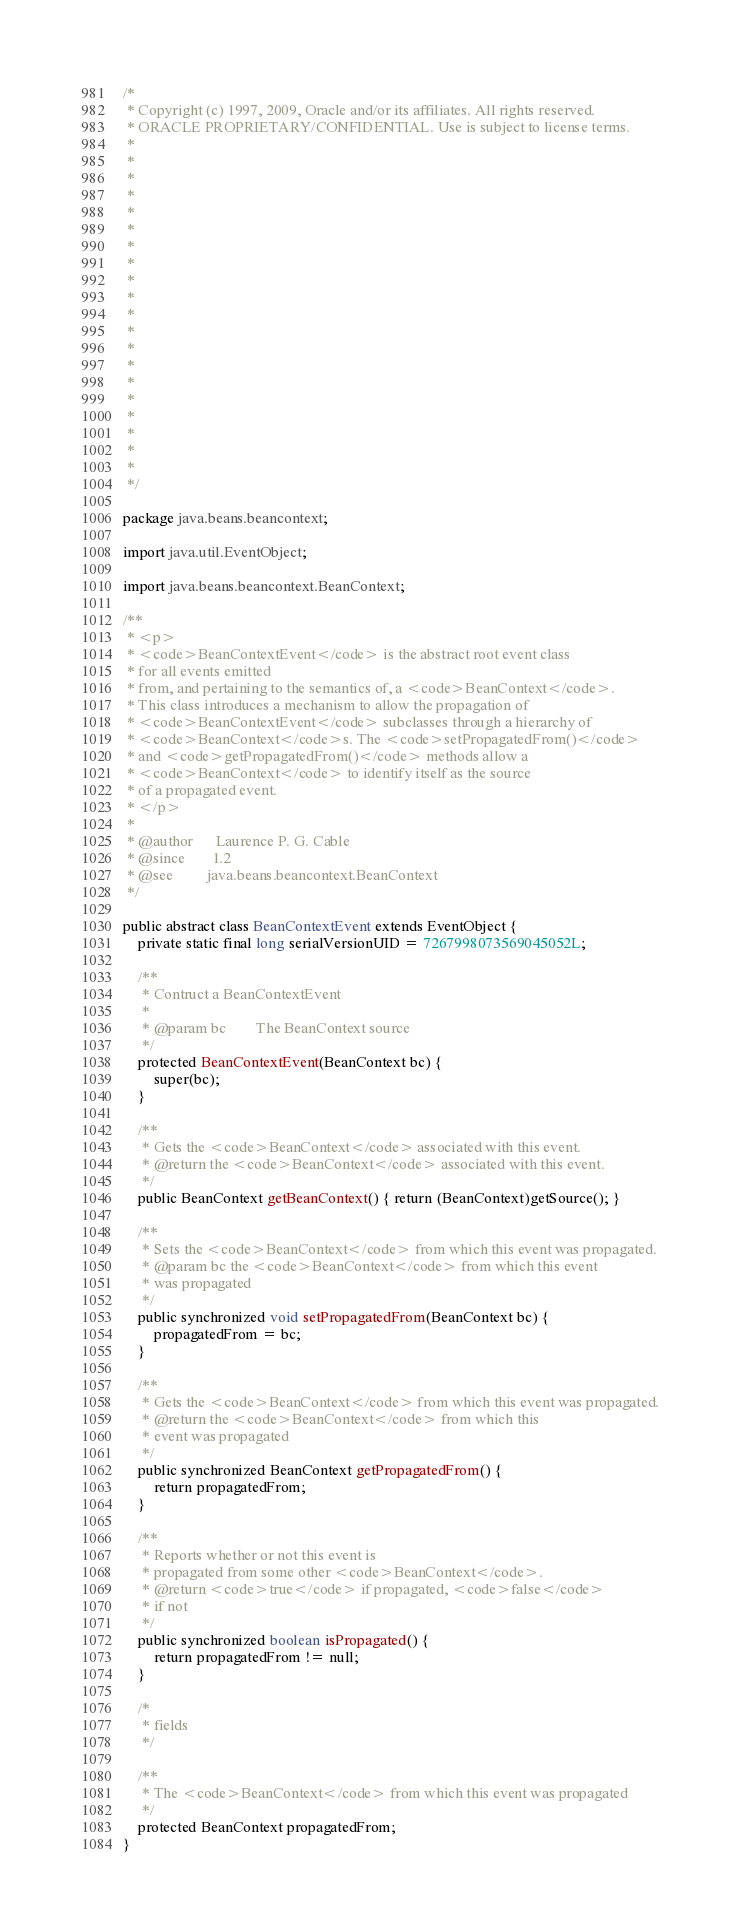Convert code to text. <code><loc_0><loc_0><loc_500><loc_500><_Java_>/*
 * Copyright (c) 1997, 2009, Oracle and/or its affiliates. All rights reserved.
 * ORACLE PROPRIETARY/CONFIDENTIAL. Use is subject to license terms.
 *
 *
 *
 *
 *
 *
 *
 *
 *
 *
 *
 *
 *
 *
 *
 *
 *
 *
 *
 *
 */

package java.beans.beancontext;

import java.util.EventObject;

import java.beans.beancontext.BeanContext;

/**
 * <p>
 * <code>BeanContextEvent</code> is the abstract root event class
 * for all events emitted
 * from, and pertaining to the semantics of, a <code>BeanContext</code>.
 * This class introduces a mechanism to allow the propagation of
 * <code>BeanContextEvent</code> subclasses through a hierarchy of
 * <code>BeanContext</code>s. The <code>setPropagatedFrom()</code>
 * and <code>getPropagatedFrom()</code> methods allow a
 * <code>BeanContext</code> to identify itself as the source
 * of a propagated event.
 * </p>
 *
 * @author      Laurence P. G. Cable
 * @since       1.2
 * @see         java.beans.beancontext.BeanContext
 */

public abstract class BeanContextEvent extends EventObject {
    private static final long serialVersionUID = 7267998073569045052L;

    /**
     * Contruct a BeanContextEvent
     *
     * @param bc        The BeanContext source
     */
    protected BeanContextEvent(BeanContext bc) {
        super(bc);
    }

    /**
     * Gets the <code>BeanContext</code> associated with this event.
     * @return the <code>BeanContext</code> associated with this event.
     */
    public BeanContext getBeanContext() { return (BeanContext)getSource(); }

    /**
     * Sets the <code>BeanContext</code> from which this event was propagated.
     * @param bc the <code>BeanContext</code> from which this event
     * was propagated
     */
    public synchronized void setPropagatedFrom(BeanContext bc) {
        propagatedFrom = bc;
    }

    /**
     * Gets the <code>BeanContext</code> from which this event was propagated.
     * @return the <code>BeanContext</code> from which this
     * event was propagated
     */
    public synchronized BeanContext getPropagatedFrom() {
        return propagatedFrom;
    }

    /**
     * Reports whether or not this event is
     * propagated from some other <code>BeanContext</code>.
     * @return <code>true</code> if propagated, <code>false</code>
     * if not
     */
    public synchronized boolean isPropagated() {
        return propagatedFrom != null;
    }

    /*
     * fields
     */

    /**
     * The <code>BeanContext</code> from which this event was propagated
     */
    protected BeanContext propagatedFrom;
}
</code> 